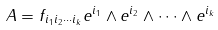Convert formula to latex. <formula><loc_0><loc_0><loc_500><loc_500>A = f _ { i _ { 1 } i _ { 2 } \cdots i _ { k } } e ^ { i _ { 1 } } \wedge e ^ { i _ { 2 } } \wedge \cdots \wedge e ^ { i _ { k } }</formula> 